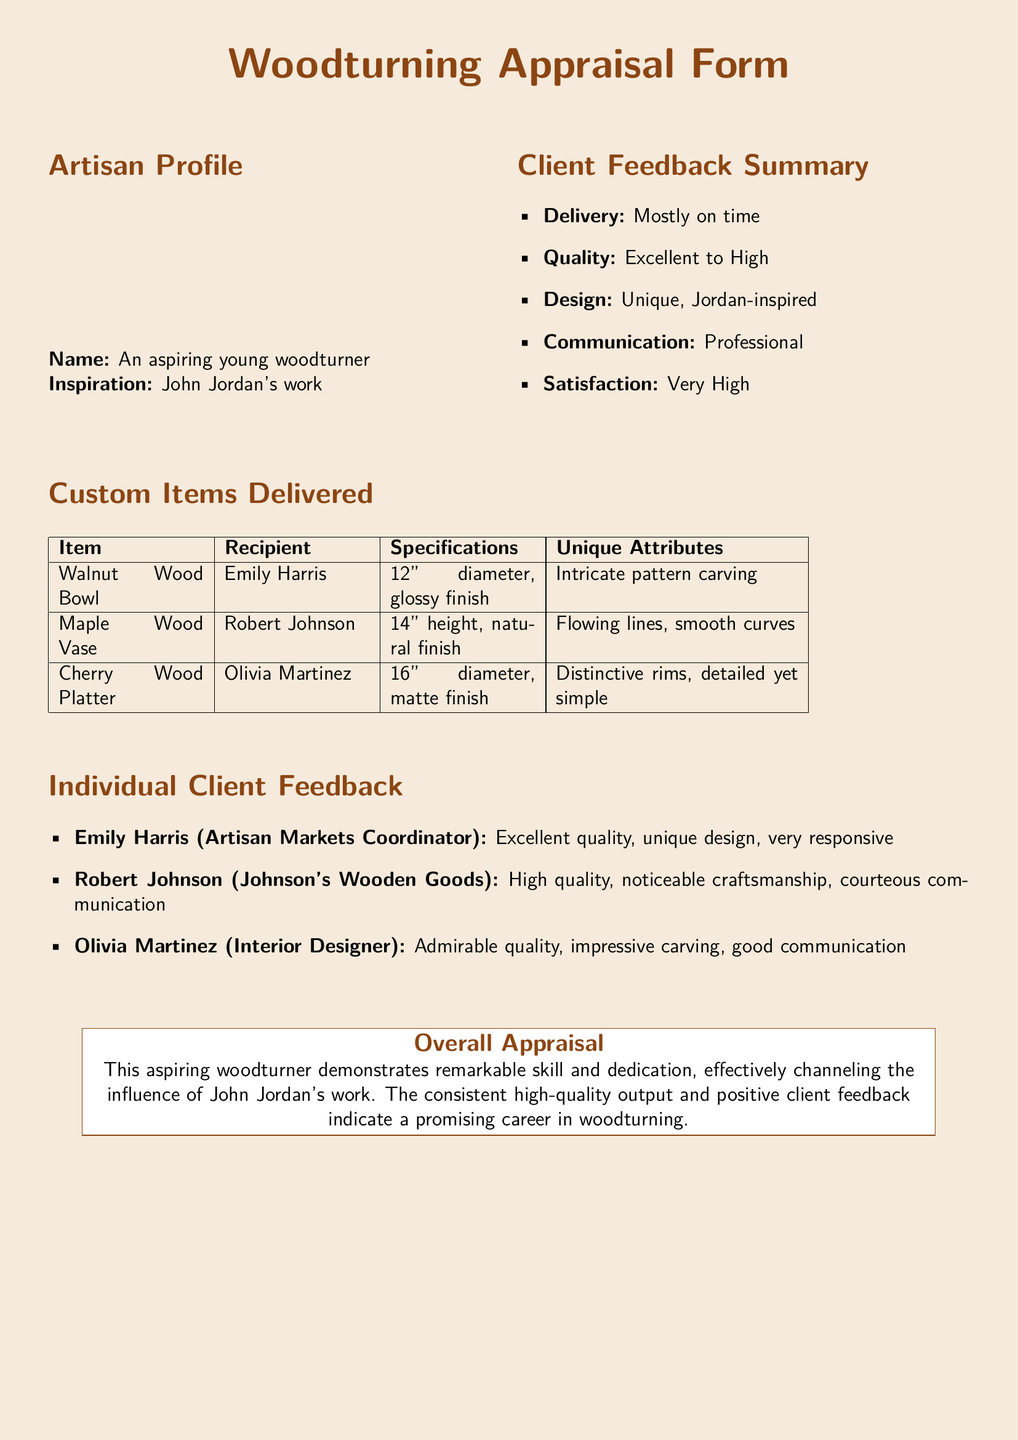What is the name of the woodturner? The document states that the name of the woodturner is "An aspiring young woodturner."
Answer: An aspiring young woodturner What type of wood is the bowl made of? The document specifies that the bowl is made of walnut wood.
Answer: Walnut wood What is the height of the maple wood vase? The specifications for the maple wood vase indicate it is 14 inches in height.
Answer: 14" Who is the recipient of the cherry wood platter? The recipient listed for the cherry wood platter is Olivia Martinez.
Answer: Olivia Martinez How did clients rate the quality of the items? The summary states the quality is rated from excellent to high, showing a range of high quality.
Answer: Excellent to High Which client mentioned impressive carving? Olivia Martinez, the interior designer, noted the impressive carving in her feedback.
Answer: Olivia Martinez What is the unique attribute of the walnut bowl? The unique attribute listed for the walnut bowl is intricate pattern carving.
Answer: Intricate pattern carving What is the feedback from Robert Johnson? Robert Johnson's feedback highlights high quality and noticeable craftsmanship.
Answer: High quality, noticeable craftsmanship What is the overall appraisal of the woodturner's skills? The overall appraisal notes the woodturner demonstrates remarkable skill and dedication.
Answer: Remarkable skill and dedication 